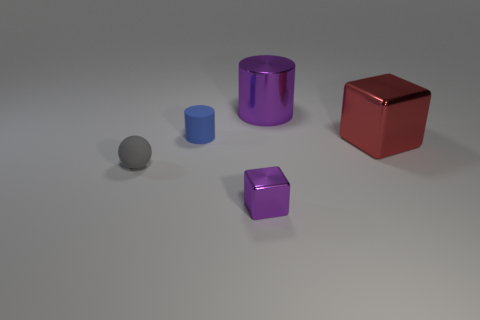Add 5 small blue matte cylinders. How many objects exist? 10 Subtract all cylinders. How many objects are left? 3 Subtract 0 brown cubes. How many objects are left? 5 Subtract all gray balls. Subtract all metallic objects. How many objects are left? 1 Add 3 tiny matte balls. How many tiny matte balls are left? 4 Add 3 small things. How many small things exist? 6 